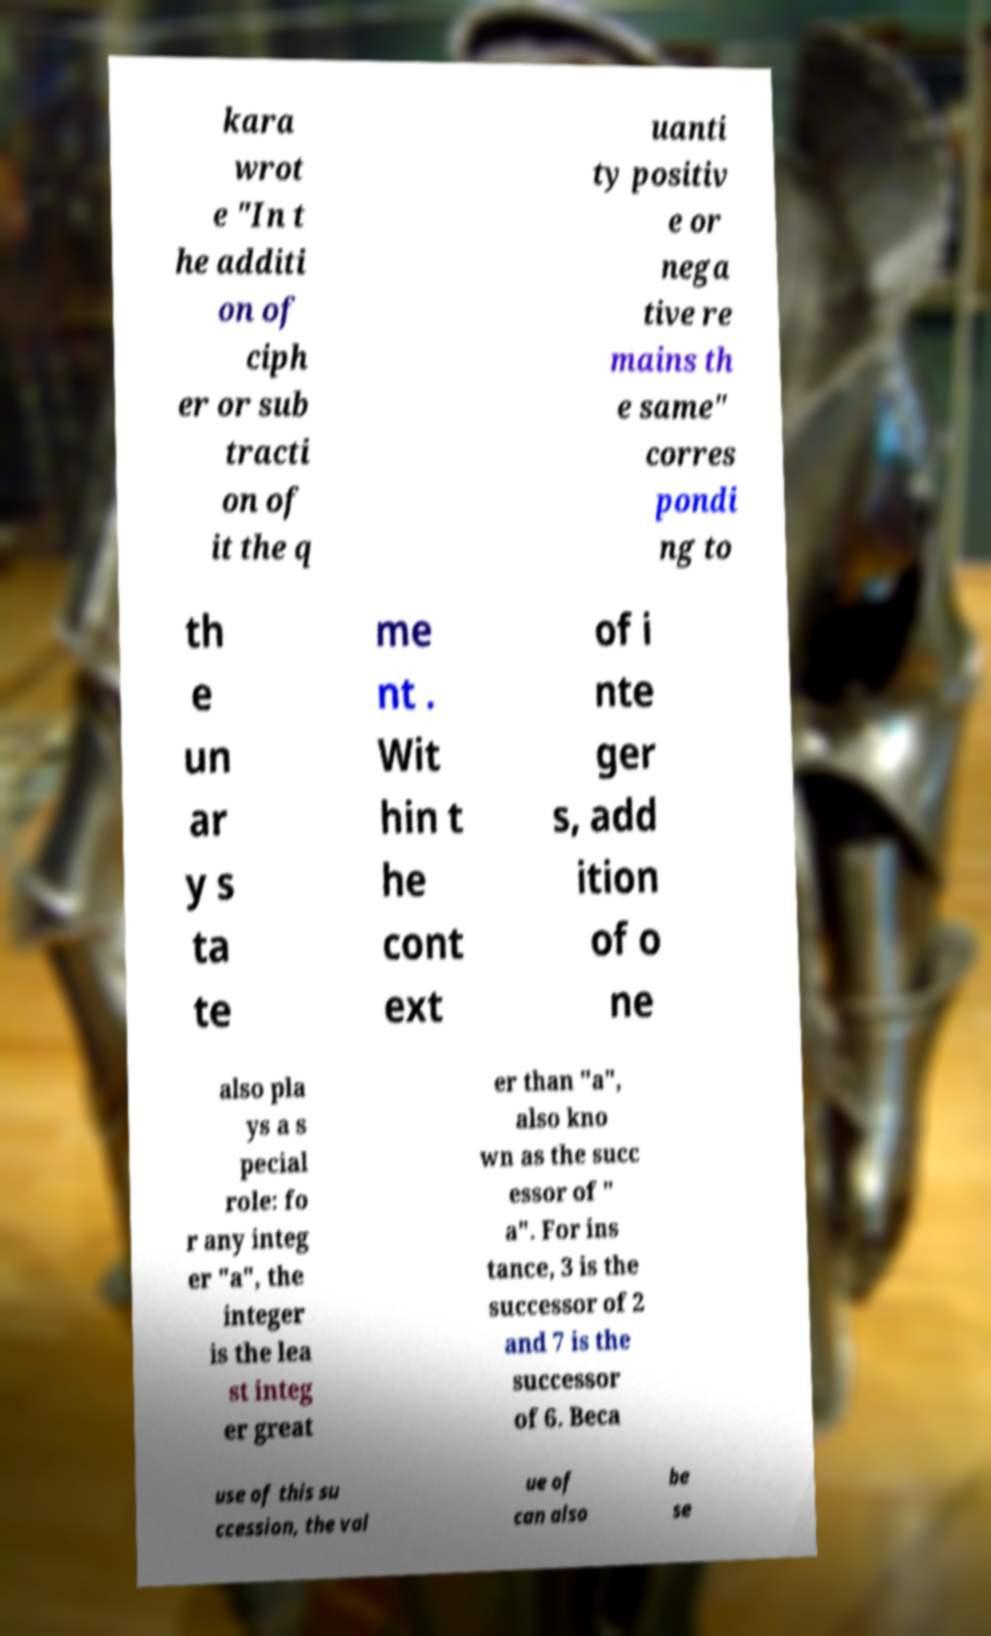Please read and relay the text visible in this image. What does it say? kara wrot e "In t he additi on of ciph er or sub tracti on of it the q uanti ty positiv e or nega tive re mains th e same" corres pondi ng to th e un ar y s ta te me nt . Wit hin t he cont ext of i nte ger s, add ition of o ne also pla ys a s pecial role: fo r any integ er "a", the integer is the lea st integ er great er than "a", also kno wn as the succ essor of " a". For ins tance, 3 is the successor of 2 and 7 is the successor of 6. Beca use of this su ccession, the val ue of can also be se 